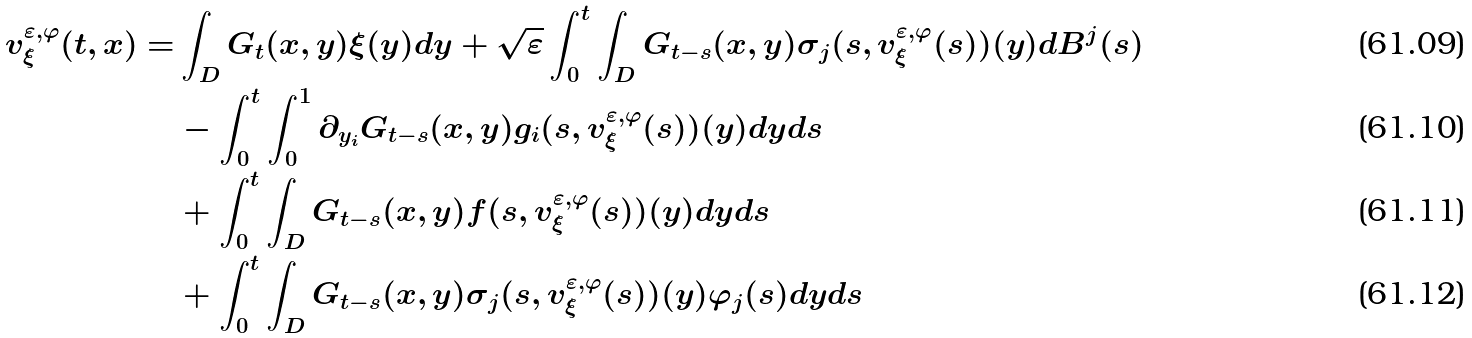Convert formula to latex. <formula><loc_0><loc_0><loc_500><loc_500>v ^ { { \varepsilon } , \varphi } _ { \xi } ( t , x ) = & \int _ { D } G _ { t } ( x , y ) \xi ( y ) d y + \sqrt { \varepsilon } \int _ { 0 } ^ { t } \int _ { D } G _ { t - s } ( x , y ) \sigma _ { j } ( s , v ^ { { \varepsilon } , \varphi } _ { \xi } ( s ) ) ( y ) d B ^ { j } ( s ) \\ & - \int _ { 0 } ^ { t } \int _ { 0 } ^ { 1 } \partial _ { y _ { i } } G _ { t - s } ( x , y ) g _ { i } ( s , v ^ { { \varepsilon } , \varphi } _ { \xi } ( s ) ) ( y ) d y d s \\ & + \int _ { 0 } ^ { t } \int _ { D } G _ { t - s } ( x , y ) f ( s , v ^ { { \varepsilon } , \varphi } _ { \xi } ( s ) ) ( y ) d y d s \\ & + \int _ { 0 } ^ { t } \int _ { D } G _ { t - s } ( x , y ) \sigma _ { j } ( s , v ^ { { \varepsilon } , \varphi } _ { \xi } ( s ) ) ( y ) \varphi _ { j } ( s ) d y d s</formula> 